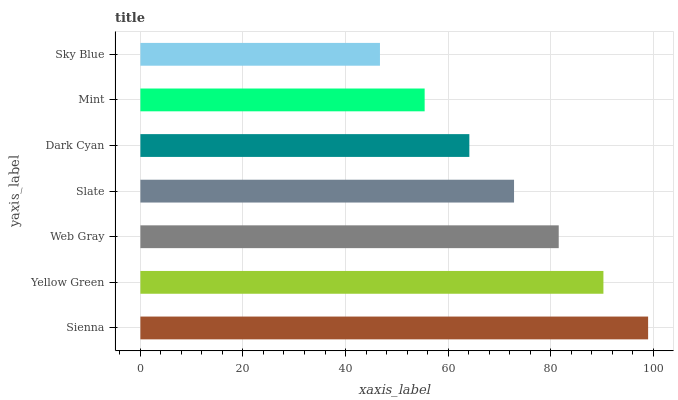Is Sky Blue the minimum?
Answer yes or no. Yes. Is Sienna the maximum?
Answer yes or no. Yes. Is Yellow Green the minimum?
Answer yes or no. No. Is Yellow Green the maximum?
Answer yes or no. No. Is Sienna greater than Yellow Green?
Answer yes or no. Yes. Is Yellow Green less than Sienna?
Answer yes or no. Yes. Is Yellow Green greater than Sienna?
Answer yes or no. No. Is Sienna less than Yellow Green?
Answer yes or no. No. Is Slate the high median?
Answer yes or no. Yes. Is Slate the low median?
Answer yes or no. Yes. Is Yellow Green the high median?
Answer yes or no. No. Is Web Gray the low median?
Answer yes or no. No. 